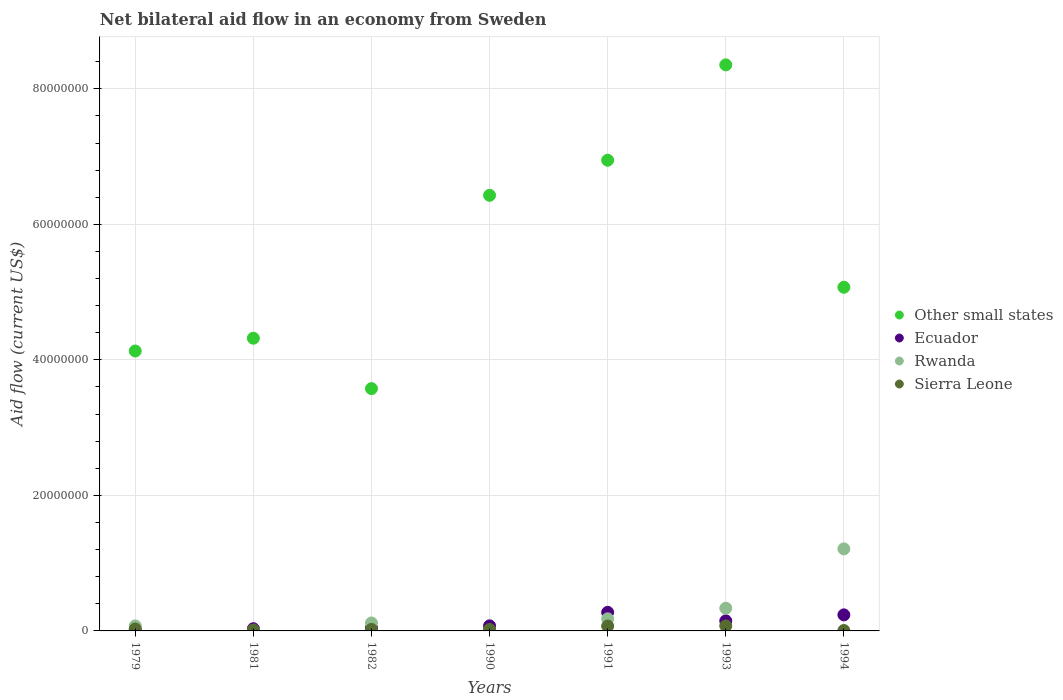What is the net bilateral aid flow in Rwanda in 1979?
Keep it short and to the point. 7.40e+05. Across all years, what is the maximum net bilateral aid flow in Ecuador?
Make the answer very short. 2.74e+06. What is the total net bilateral aid flow in Rwanda in the graph?
Offer a terse response. 1.93e+07. What is the difference between the net bilateral aid flow in Ecuador in 1982 and that in 1994?
Ensure brevity in your answer.  -1.93e+06. What is the difference between the net bilateral aid flow in Ecuador in 1979 and the net bilateral aid flow in Other small states in 1990?
Give a very brief answer. -6.42e+07. What is the average net bilateral aid flow in Ecuador per year?
Offer a terse response. 1.18e+06. In the year 1993, what is the difference between the net bilateral aid flow in Ecuador and net bilateral aid flow in Sierra Leone?
Your answer should be very brief. 7.50e+05. In how many years, is the net bilateral aid flow in Rwanda greater than 52000000 US$?
Provide a succinct answer. 0. What is the ratio of the net bilateral aid flow in Sierra Leone in 1981 to that in 1990?
Keep it short and to the point. 0.67. Is the net bilateral aid flow in Sierra Leone in 1982 less than that in 1994?
Your response must be concise. No. Is the difference between the net bilateral aid flow in Ecuador in 1982 and 1990 greater than the difference between the net bilateral aid flow in Sierra Leone in 1982 and 1990?
Your answer should be very brief. No. What is the difference between the highest and the second highest net bilateral aid flow in Other small states?
Give a very brief answer. 1.41e+07. What is the difference between the highest and the lowest net bilateral aid flow in Ecuador?
Your answer should be compact. 2.61e+06. Is the sum of the net bilateral aid flow in Other small states in 1990 and 1994 greater than the maximum net bilateral aid flow in Sierra Leone across all years?
Offer a very short reply. Yes. Is it the case that in every year, the sum of the net bilateral aid flow in Rwanda and net bilateral aid flow in Sierra Leone  is greater than the net bilateral aid flow in Other small states?
Your response must be concise. No. Does the net bilateral aid flow in Sierra Leone monotonically increase over the years?
Your response must be concise. No. Is the net bilateral aid flow in Ecuador strictly greater than the net bilateral aid flow in Rwanda over the years?
Offer a very short reply. No. Is the net bilateral aid flow in Ecuador strictly less than the net bilateral aid flow in Sierra Leone over the years?
Your response must be concise. No. How many dotlines are there?
Give a very brief answer. 4. How many years are there in the graph?
Provide a succinct answer. 7. Does the graph contain grids?
Provide a succinct answer. Yes. Where does the legend appear in the graph?
Provide a succinct answer. Center right. What is the title of the graph?
Provide a short and direct response. Net bilateral aid flow in an economy from Sweden. What is the label or title of the X-axis?
Make the answer very short. Years. What is the Aid flow (current US$) of Other small states in 1979?
Make the answer very short. 4.13e+07. What is the Aid flow (current US$) of Rwanda in 1979?
Your answer should be compact. 7.40e+05. What is the Aid flow (current US$) in Other small states in 1981?
Your answer should be compact. 4.32e+07. What is the Aid flow (current US$) in Ecuador in 1981?
Provide a short and direct response. 3.30e+05. What is the Aid flow (current US$) of Rwanda in 1981?
Keep it short and to the point. 3.00e+04. What is the Aid flow (current US$) of Sierra Leone in 1981?
Your answer should be very brief. 1.40e+05. What is the Aid flow (current US$) in Other small states in 1982?
Your answer should be very brief. 3.58e+07. What is the Aid flow (current US$) of Ecuador in 1982?
Provide a succinct answer. 4.40e+05. What is the Aid flow (current US$) of Rwanda in 1982?
Make the answer very short. 1.17e+06. What is the Aid flow (current US$) in Other small states in 1990?
Your answer should be very brief. 6.43e+07. What is the Aid flow (current US$) of Ecuador in 1990?
Offer a terse response. 7.50e+05. What is the Aid flow (current US$) of Sierra Leone in 1990?
Offer a terse response. 2.10e+05. What is the Aid flow (current US$) in Other small states in 1991?
Your answer should be compact. 6.95e+07. What is the Aid flow (current US$) of Ecuador in 1991?
Provide a short and direct response. 2.74e+06. What is the Aid flow (current US$) in Rwanda in 1991?
Provide a short and direct response. 1.79e+06. What is the Aid flow (current US$) of Sierra Leone in 1991?
Provide a short and direct response. 7.20e+05. What is the Aid flow (current US$) in Other small states in 1993?
Make the answer very short. 8.35e+07. What is the Aid flow (current US$) of Ecuador in 1993?
Your answer should be very brief. 1.49e+06. What is the Aid flow (current US$) in Rwanda in 1993?
Your response must be concise. 3.35e+06. What is the Aid flow (current US$) of Sierra Leone in 1993?
Your response must be concise. 7.40e+05. What is the Aid flow (current US$) in Other small states in 1994?
Offer a very short reply. 5.07e+07. What is the Aid flow (current US$) of Ecuador in 1994?
Your answer should be compact. 2.37e+06. What is the Aid flow (current US$) of Rwanda in 1994?
Your answer should be very brief. 1.21e+07. Across all years, what is the maximum Aid flow (current US$) in Other small states?
Your response must be concise. 8.35e+07. Across all years, what is the maximum Aid flow (current US$) of Ecuador?
Make the answer very short. 2.74e+06. Across all years, what is the maximum Aid flow (current US$) of Rwanda?
Your answer should be compact. 1.21e+07. Across all years, what is the maximum Aid flow (current US$) of Sierra Leone?
Your answer should be compact. 7.40e+05. Across all years, what is the minimum Aid flow (current US$) of Other small states?
Offer a very short reply. 3.58e+07. Across all years, what is the minimum Aid flow (current US$) of Ecuador?
Make the answer very short. 1.30e+05. Across all years, what is the minimum Aid flow (current US$) of Sierra Leone?
Provide a succinct answer. 6.00e+04. What is the total Aid flow (current US$) in Other small states in the graph?
Keep it short and to the point. 3.88e+08. What is the total Aid flow (current US$) of Ecuador in the graph?
Your answer should be compact. 8.25e+06. What is the total Aid flow (current US$) of Rwanda in the graph?
Your answer should be compact. 1.93e+07. What is the total Aid flow (current US$) of Sierra Leone in the graph?
Provide a short and direct response. 2.39e+06. What is the difference between the Aid flow (current US$) of Other small states in 1979 and that in 1981?
Keep it short and to the point. -1.89e+06. What is the difference between the Aid flow (current US$) in Ecuador in 1979 and that in 1981?
Give a very brief answer. -2.00e+05. What is the difference between the Aid flow (current US$) of Rwanda in 1979 and that in 1981?
Give a very brief answer. 7.10e+05. What is the difference between the Aid flow (current US$) in Sierra Leone in 1979 and that in 1981?
Offer a terse response. 1.50e+05. What is the difference between the Aid flow (current US$) in Other small states in 1979 and that in 1982?
Keep it short and to the point. 5.55e+06. What is the difference between the Aid flow (current US$) in Ecuador in 1979 and that in 1982?
Provide a short and direct response. -3.10e+05. What is the difference between the Aid flow (current US$) of Rwanda in 1979 and that in 1982?
Ensure brevity in your answer.  -4.30e+05. What is the difference between the Aid flow (current US$) in Other small states in 1979 and that in 1990?
Offer a terse response. -2.30e+07. What is the difference between the Aid flow (current US$) in Ecuador in 1979 and that in 1990?
Give a very brief answer. -6.20e+05. What is the difference between the Aid flow (current US$) in Rwanda in 1979 and that in 1990?
Offer a terse response. 6.10e+05. What is the difference between the Aid flow (current US$) in Sierra Leone in 1979 and that in 1990?
Offer a very short reply. 8.00e+04. What is the difference between the Aid flow (current US$) in Other small states in 1979 and that in 1991?
Ensure brevity in your answer.  -2.82e+07. What is the difference between the Aid flow (current US$) in Ecuador in 1979 and that in 1991?
Offer a terse response. -2.61e+06. What is the difference between the Aid flow (current US$) of Rwanda in 1979 and that in 1991?
Your response must be concise. -1.05e+06. What is the difference between the Aid flow (current US$) of Sierra Leone in 1979 and that in 1991?
Provide a short and direct response. -4.30e+05. What is the difference between the Aid flow (current US$) in Other small states in 1979 and that in 1993?
Provide a short and direct response. -4.22e+07. What is the difference between the Aid flow (current US$) of Ecuador in 1979 and that in 1993?
Your answer should be compact. -1.36e+06. What is the difference between the Aid flow (current US$) of Rwanda in 1979 and that in 1993?
Your answer should be very brief. -2.61e+06. What is the difference between the Aid flow (current US$) of Sierra Leone in 1979 and that in 1993?
Your response must be concise. -4.50e+05. What is the difference between the Aid flow (current US$) of Other small states in 1979 and that in 1994?
Your answer should be compact. -9.41e+06. What is the difference between the Aid flow (current US$) in Ecuador in 1979 and that in 1994?
Ensure brevity in your answer.  -2.24e+06. What is the difference between the Aid flow (current US$) in Rwanda in 1979 and that in 1994?
Ensure brevity in your answer.  -1.14e+07. What is the difference between the Aid flow (current US$) in Sierra Leone in 1979 and that in 1994?
Offer a terse response. 2.30e+05. What is the difference between the Aid flow (current US$) in Other small states in 1981 and that in 1982?
Make the answer very short. 7.44e+06. What is the difference between the Aid flow (current US$) of Ecuador in 1981 and that in 1982?
Ensure brevity in your answer.  -1.10e+05. What is the difference between the Aid flow (current US$) of Rwanda in 1981 and that in 1982?
Give a very brief answer. -1.14e+06. What is the difference between the Aid flow (current US$) in Sierra Leone in 1981 and that in 1982?
Offer a very short reply. -9.00e+04. What is the difference between the Aid flow (current US$) of Other small states in 1981 and that in 1990?
Provide a succinct answer. -2.11e+07. What is the difference between the Aid flow (current US$) in Ecuador in 1981 and that in 1990?
Your answer should be very brief. -4.20e+05. What is the difference between the Aid flow (current US$) of Sierra Leone in 1981 and that in 1990?
Your answer should be compact. -7.00e+04. What is the difference between the Aid flow (current US$) in Other small states in 1981 and that in 1991?
Provide a succinct answer. -2.63e+07. What is the difference between the Aid flow (current US$) in Ecuador in 1981 and that in 1991?
Provide a short and direct response. -2.41e+06. What is the difference between the Aid flow (current US$) in Rwanda in 1981 and that in 1991?
Give a very brief answer. -1.76e+06. What is the difference between the Aid flow (current US$) in Sierra Leone in 1981 and that in 1991?
Offer a very short reply. -5.80e+05. What is the difference between the Aid flow (current US$) of Other small states in 1981 and that in 1993?
Ensure brevity in your answer.  -4.03e+07. What is the difference between the Aid flow (current US$) of Ecuador in 1981 and that in 1993?
Offer a very short reply. -1.16e+06. What is the difference between the Aid flow (current US$) of Rwanda in 1981 and that in 1993?
Provide a short and direct response. -3.32e+06. What is the difference between the Aid flow (current US$) in Sierra Leone in 1981 and that in 1993?
Your answer should be compact. -6.00e+05. What is the difference between the Aid flow (current US$) in Other small states in 1981 and that in 1994?
Offer a very short reply. -7.52e+06. What is the difference between the Aid flow (current US$) in Ecuador in 1981 and that in 1994?
Provide a short and direct response. -2.04e+06. What is the difference between the Aid flow (current US$) of Rwanda in 1981 and that in 1994?
Make the answer very short. -1.21e+07. What is the difference between the Aid flow (current US$) in Other small states in 1982 and that in 1990?
Provide a short and direct response. -2.85e+07. What is the difference between the Aid flow (current US$) of Ecuador in 1982 and that in 1990?
Offer a terse response. -3.10e+05. What is the difference between the Aid flow (current US$) in Rwanda in 1982 and that in 1990?
Ensure brevity in your answer.  1.04e+06. What is the difference between the Aid flow (current US$) of Other small states in 1982 and that in 1991?
Keep it short and to the point. -3.37e+07. What is the difference between the Aid flow (current US$) of Ecuador in 1982 and that in 1991?
Provide a succinct answer. -2.30e+06. What is the difference between the Aid flow (current US$) in Rwanda in 1982 and that in 1991?
Offer a terse response. -6.20e+05. What is the difference between the Aid flow (current US$) in Sierra Leone in 1982 and that in 1991?
Ensure brevity in your answer.  -4.90e+05. What is the difference between the Aid flow (current US$) in Other small states in 1982 and that in 1993?
Offer a terse response. -4.78e+07. What is the difference between the Aid flow (current US$) of Ecuador in 1982 and that in 1993?
Provide a short and direct response. -1.05e+06. What is the difference between the Aid flow (current US$) of Rwanda in 1982 and that in 1993?
Offer a terse response. -2.18e+06. What is the difference between the Aid flow (current US$) in Sierra Leone in 1982 and that in 1993?
Offer a very short reply. -5.10e+05. What is the difference between the Aid flow (current US$) in Other small states in 1982 and that in 1994?
Provide a short and direct response. -1.50e+07. What is the difference between the Aid flow (current US$) in Ecuador in 1982 and that in 1994?
Give a very brief answer. -1.93e+06. What is the difference between the Aid flow (current US$) of Rwanda in 1982 and that in 1994?
Offer a terse response. -1.09e+07. What is the difference between the Aid flow (current US$) in Sierra Leone in 1982 and that in 1994?
Your answer should be very brief. 1.70e+05. What is the difference between the Aid flow (current US$) of Other small states in 1990 and that in 1991?
Offer a terse response. -5.18e+06. What is the difference between the Aid flow (current US$) in Ecuador in 1990 and that in 1991?
Your answer should be compact. -1.99e+06. What is the difference between the Aid flow (current US$) of Rwanda in 1990 and that in 1991?
Make the answer very short. -1.66e+06. What is the difference between the Aid flow (current US$) of Sierra Leone in 1990 and that in 1991?
Your response must be concise. -5.10e+05. What is the difference between the Aid flow (current US$) of Other small states in 1990 and that in 1993?
Provide a succinct answer. -1.92e+07. What is the difference between the Aid flow (current US$) of Ecuador in 1990 and that in 1993?
Your answer should be very brief. -7.40e+05. What is the difference between the Aid flow (current US$) of Rwanda in 1990 and that in 1993?
Provide a succinct answer. -3.22e+06. What is the difference between the Aid flow (current US$) in Sierra Leone in 1990 and that in 1993?
Make the answer very short. -5.30e+05. What is the difference between the Aid flow (current US$) of Other small states in 1990 and that in 1994?
Keep it short and to the point. 1.36e+07. What is the difference between the Aid flow (current US$) of Ecuador in 1990 and that in 1994?
Your answer should be very brief. -1.62e+06. What is the difference between the Aid flow (current US$) in Rwanda in 1990 and that in 1994?
Provide a succinct answer. -1.20e+07. What is the difference between the Aid flow (current US$) of Sierra Leone in 1990 and that in 1994?
Make the answer very short. 1.50e+05. What is the difference between the Aid flow (current US$) of Other small states in 1991 and that in 1993?
Ensure brevity in your answer.  -1.41e+07. What is the difference between the Aid flow (current US$) in Ecuador in 1991 and that in 1993?
Your answer should be very brief. 1.25e+06. What is the difference between the Aid flow (current US$) in Rwanda in 1991 and that in 1993?
Your answer should be very brief. -1.56e+06. What is the difference between the Aid flow (current US$) in Sierra Leone in 1991 and that in 1993?
Provide a short and direct response. -2.00e+04. What is the difference between the Aid flow (current US$) in Other small states in 1991 and that in 1994?
Keep it short and to the point. 1.88e+07. What is the difference between the Aid flow (current US$) of Ecuador in 1991 and that in 1994?
Offer a terse response. 3.70e+05. What is the difference between the Aid flow (current US$) of Rwanda in 1991 and that in 1994?
Keep it short and to the point. -1.03e+07. What is the difference between the Aid flow (current US$) in Other small states in 1993 and that in 1994?
Keep it short and to the point. 3.28e+07. What is the difference between the Aid flow (current US$) in Ecuador in 1993 and that in 1994?
Your answer should be very brief. -8.80e+05. What is the difference between the Aid flow (current US$) in Rwanda in 1993 and that in 1994?
Keep it short and to the point. -8.76e+06. What is the difference between the Aid flow (current US$) in Sierra Leone in 1993 and that in 1994?
Give a very brief answer. 6.80e+05. What is the difference between the Aid flow (current US$) in Other small states in 1979 and the Aid flow (current US$) in Ecuador in 1981?
Ensure brevity in your answer.  4.10e+07. What is the difference between the Aid flow (current US$) of Other small states in 1979 and the Aid flow (current US$) of Rwanda in 1981?
Offer a terse response. 4.13e+07. What is the difference between the Aid flow (current US$) of Other small states in 1979 and the Aid flow (current US$) of Sierra Leone in 1981?
Make the answer very short. 4.12e+07. What is the difference between the Aid flow (current US$) of Ecuador in 1979 and the Aid flow (current US$) of Sierra Leone in 1981?
Keep it short and to the point. -10000. What is the difference between the Aid flow (current US$) of Rwanda in 1979 and the Aid flow (current US$) of Sierra Leone in 1981?
Provide a succinct answer. 6.00e+05. What is the difference between the Aid flow (current US$) in Other small states in 1979 and the Aid flow (current US$) in Ecuador in 1982?
Your response must be concise. 4.09e+07. What is the difference between the Aid flow (current US$) of Other small states in 1979 and the Aid flow (current US$) of Rwanda in 1982?
Give a very brief answer. 4.01e+07. What is the difference between the Aid flow (current US$) of Other small states in 1979 and the Aid flow (current US$) of Sierra Leone in 1982?
Make the answer very short. 4.11e+07. What is the difference between the Aid flow (current US$) in Ecuador in 1979 and the Aid flow (current US$) in Rwanda in 1982?
Ensure brevity in your answer.  -1.04e+06. What is the difference between the Aid flow (current US$) of Ecuador in 1979 and the Aid flow (current US$) of Sierra Leone in 1982?
Your answer should be compact. -1.00e+05. What is the difference between the Aid flow (current US$) of Rwanda in 1979 and the Aid flow (current US$) of Sierra Leone in 1982?
Ensure brevity in your answer.  5.10e+05. What is the difference between the Aid flow (current US$) in Other small states in 1979 and the Aid flow (current US$) in Ecuador in 1990?
Make the answer very short. 4.06e+07. What is the difference between the Aid flow (current US$) of Other small states in 1979 and the Aid flow (current US$) of Rwanda in 1990?
Keep it short and to the point. 4.12e+07. What is the difference between the Aid flow (current US$) in Other small states in 1979 and the Aid flow (current US$) in Sierra Leone in 1990?
Make the answer very short. 4.11e+07. What is the difference between the Aid flow (current US$) of Ecuador in 1979 and the Aid flow (current US$) of Rwanda in 1990?
Ensure brevity in your answer.  0. What is the difference between the Aid flow (current US$) in Ecuador in 1979 and the Aid flow (current US$) in Sierra Leone in 1990?
Give a very brief answer. -8.00e+04. What is the difference between the Aid flow (current US$) in Rwanda in 1979 and the Aid flow (current US$) in Sierra Leone in 1990?
Give a very brief answer. 5.30e+05. What is the difference between the Aid flow (current US$) in Other small states in 1979 and the Aid flow (current US$) in Ecuador in 1991?
Give a very brief answer. 3.86e+07. What is the difference between the Aid flow (current US$) in Other small states in 1979 and the Aid flow (current US$) in Rwanda in 1991?
Your response must be concise. 3.95e+07. What is the difference between the Aid flow (current US$) of Other small states in 1979 and the Aid flow (current US$) of Sierra Leone in 1991?
Offer a very short reply. 4.06e+07. What is the difference between the Aid flow (current US$) of Ecuador in 1979 and the Aid flow (current US$) of Rwanda in 1991?
Your response must be concise. -1.66e+06. What is the difference between the Aid flow (current US$) in Ecuador in 1979 and the Aid flow (current US$) in Sierra Leone in 1991?
Offer a very short reply. -5.90e+05. What is the difference between the Aid flow (current US$) in Rwanda in 1979 and the Aid flow (current US$) in Sierra Leone in 1991?
Ensure brevity in your answer.  2.00e+04. What is the difference between the Aid flow (current US$) of Other small states in 1979 and the Aid flow (current US$) of Ecuador in 1993?
Offer a very short reply. 3.98e+07. What is the difference between the Aid flow (current US$) in Other small states in 1979 and the Aid flow (current US$) in Rwanda in 1993?
Your response must be concise. 3.80e+07. What is the difference between the Aid flow (current US$) of Other small states in 1979 and the Aid flow (current US$) of Sierra Leone in 1993?
Make the answer very short. 4.06e+07. What is the difference between the Aid flow (current US$) of Ecuador in 1979 and the Aid flow (current US$) of Rwanda in 1993?
Give a very brief answer. -3.22e+06. What is the difference between the Aid flow (current US$) in Ecuador in 1979 and the Aid flow (current US$) in Sierra Leone in 1993?
Your response must be concise. -6.10e+05. What is the difference between the Aid flow (current US$) of Rwanda in 1979 and the Aid flow (current US$) of Sierra Leone in 1993?
Your answer should be very brief. 0. What is the difference between the Aid flow (current US$) of Other small states in 1979 and the Aid flow (current US$) of Ecuador in 1994?
Ensure brevity in your answer.  3.89e+07. What is the difference between the Aid flow (current US$) in Other small states in 1979 and the Aid flow (current US$) in Rwanda in 1994?
Make the answer very short. 2.92e+07. What is the difference between the Aid flow (current US$) in Other small states in 1979 and the Aid flow (current US$) in Sierra Leone in 1994?
Make the answer very short. 4.12e+07. What is the difference between the Aid flow (current US$) in Ecuador in 1979 and the Aid flow (current US$) in Rwanda in 1994?
Give a very brief answer. -1.20e+07. What is the difference between the Aid flow (current US$) in Rwanda in 1979 and the Aid flow (current US$) in Sierra Leone in 1994?
Ensure brevity in your answer.  6.80e+05. What is the difference between the Aid flow (current US$) of Other small states in 1981 and the Aid flow (current US$) of Ecuador in 1982?
Offer a terse response. 4.28e+07. What is the difference between the Aid flow (current US$) in Other small states in 1981 and the Aid flow (current US$) in Rwanda in 1982?
Your answer should be very brief. 4.20e+07. What is the difference between the Aid flow (current US$) of Other small states in 1981 and the Aid flow (current US$) of Sierra Leone in 1982?
Your answer should be very brief. 4.30e+07. What is the difference between the Aid flow (current US$) of Ecuador in 1981 and the Aid flow (current US$) of Rwanda in 1982?
Offer a terse response. -8.40e+05. What is the difference between the Aid flow (current US$) in Rwanda in 1981 and the Aid flow (current US$) in Sierra Leone in 1982?
Provide a short and direct response. -2.00e+05. What is the difference between the Aid flow (current US$) of Other small states in 1981 and the Aid flow (current US$) of Ecuador in 1990?
Offer a very short reply. 4.24e+07. What is the difference between the Aid flow (current US$) of Other small states in 1981 and the Aid flow (current US$) of Rwanda in 1990?
Make the answer very short. 4.31e+07. What is the difference between the Aid flow (current US$) in Other small states in 1981 and the Aid flow (current US$) in Sierra Leone in 1990?
Your answer should be compact. 4.30e+07. What is the difference between the Aid flow (current US$) of Ecuador in 1981 and the Aid flow (current US$) of Rwanda in 1990?
Your answer should be very brief. 2.00e+05. What is the difference between the Aid flow (current US$) in Ecuador in 1981 and the Aid flow (current US$) in Sierra Leone in 1990?
Provide a succinct answer. 1.20e+05. What is the difference between the Aid flow (current US$) of Rwanda in 1981 and the Aid flow (current US$) of Sierra Leone in 1990?
Offer a terse response. -1.80e+05. What is the difference between the Aid flow (current US$) of Other small states in 1981 and the Aid flow (current US$) of Ecuador in 1991?
Your response must be concise. 4.05e+07. What is the difference between the Aid flow (current US$) in Other small states in 1981 and the Aid flow (current US$) in Rwanda in 1991?
Keep it short and to the point. 4.14e+07. What is the difference between the Aid flow (current US$) in Other small states in 1981 and the Aid flow (current US$) in Sierra Leone in 1991?
Offer a terse response. 4.25e+07. What is the difference between the Aid flow (current US$) of Ecuador in 1981 and the Aid flow (current US$) of Rwanda in 1991?
Provide a short and direct response. -1.46e+06. What is the difference between the Aid flow (current US$) of Ecuador in 1981 and the Aid flow (current US$) of Sierra Leone in 1991?
Offer a very short reply. -3.90e+05. What is the difference between the Aid flow (current US$) of Rwanda in 1981 and the Aid flow (current US$) of Sierra Leone in 1991?
Offer a terse response. -6.90e+05. What is the difference between the Aid flow (current US$) in Other small states in 1981 and the Aid flow (current US$) in Ecuador in 1993?
Offer a very short reply. 4.17e+07. What is the difference between the Aid flow (current US$) in Other small states in 1981 and the Aid flow (current US$) in Rwanda in 1993?
Offer a terse response. 3.98e+07. What is the difference between the Aid flow (current US$) in Other small states in 1981 and the Aid flow (current US$) in Sierra Leone in 1993?
Provide a succinct answer. 4.25e+07. What is the difference between the Aid flow (current US$) in Ecuador in 1981 and the Aid flow (current US$) in Rwanda in 1993?
Provide a succinct answer. -3.02e+06. What is the difference between the Aid flow (current US$) of Ecuador in 1981 and the Aid flow (current US$) of Sierra Leone in 1993?
Make the answer very short. -4.10e+05. What is the difference between the Aid flow (current US$) of Rwanda in 1981 and the Aid flow (current US$) of Sierra Leone in 1993?
Give a very brief answer. -7.10e+05. What is the difference between the Aid flow (current US$) in Other small states in 1981 and the Aid flow (current US$) in Ecuador in 1994?
Your response must be concise. 4.08e+07. What is the difference between the Aid flow (current US$) of Other small states in 1981 and the Aid flow (current US$) of Rwanda in 1994?
Offer a very short reply. 3.11e+07. What is the difference between the Aid flow (current US$) in Other small states in 1981 and the Aid flow (current US$) in Sierra Leone in 1994?
Provide a short and direct response. 4.31e+07. What is the difference between the Aid flow (current US$) in Ecuador in 1981 and the Aid flow (current US$) in Rwanda in 1994?
Offer a very short reply. -1.18e+07. What is the difference between the Aid flow (current US$) in Ecuador in 1981 and the Aid flow (current US$) in Sierra Leone in 1994?
Ensure brevity in your answer.  2.70e+05. What is the difference between the Aid flow (current US$) in Other small states in 1982 and the Aid flow (current US$) in Ecuador in 1990?
Make the answer very short. 3.50e+07. What is the difference between the Aid flow (current US$) in Other small states in 1982 and the Aid flow (current US$) in Rwanda in 1990?
Provide a succinct answer. 3.56e+07. What is the difference between the Aid flow (current US$) in Other small states in 1982 and the Aid flow (current US$) in Sierra Leone in 1990?
Offer a terse response. 3.56e+07. What is the difference between the Aid flow (current US$) of Rwanda in 1982 and the Aid flow (current US$) of Sierra Leone in 1990?
Your answer should be very brief. 9.60e+05. What is the difference between the Aid flow (current US$) of Other small states in 1982 and the Aid flow (current US$) of Ecuador in 1991?
Give a very brief answer. 3.30e+07. What is the difference between the Aid flow (current US$) in Other small states in 1982 and the Aid flow (current US$) in Rwanda in 1991?
Offer a very short reply. 3.40e+07. What is the difference between the Aid flow (current US$) in Other small states in 1982 and the Aid flow (current US$) in Sierra Leone in 1991?
Ensure brevity in your answer.  3.50e+07. What is the difference between the Aid flow (current US$) in Ecuador in 1982 and the Aid flow (current US$) in Rwanda in 1991?
Your answer should be compact. -1.35e+06. What is the difference between the Aid flow (current US$) in Ecuador in 1982 and the Aid flow (current US$) in Sierra Leone in 1991?
Your response must be concise. -2.80e+05. What is the difference between the Aid flow (current US$) of Other small states in 1982 and the Aid flow (current US$) of Ecuador in 1993?
Your answer should be very brief. 3.43e+07. What is the difference between the Aid flow (current US$) in Other small states in 1982 and the Aid flow (current US$) in Rwanda in 1993?
Make the answer very short. 3.24e+07. What is the difference between the Aid flow (current US$) in Other small states in 1982 and the Aid flow (current US$) in Sierra Leone in 1993?
Your response must be concise. 3.50e+07. What is the difference between the Aid flow (current US$) in Ecuador in 1982 and the Aid flow (current US$) in Rwanda in 1993?
Provide a short and direct response. -2.91e+06. What is the difference between the Aid flow (current US$) in Other small states in 1982 and the Aid flow (current US$) in Ecuador in 1994?
Your response must be concise. 3.34e+07. What is the difference between the Aid flow (current US$) of Other small states in 1982 and the Aid flow (current US$) of Rwanda in 1994?
Provide a succinct answer. 2.36e+07. What is the difference between the Aid flow (current US$) in Other small states in 1982 and the Aid flow (current US$) in Sierra Leone in 1994?
Offer a very short reply. 3.57e+07. What is the difference between the Aid flow (current US$) in Ecuador in 1982 and the Aid flow (current US$) in Rwanda in 1994?
Keep it short and to the point. -1.17e+07. What is the difference between the Aid flow (current US$) in Rwanda in 1982 and the Aid flow (current US$) in Sierra Leone in 1994?
Offer a terse response. 1.11e+06. What is the difference between the Aid flow (current US$) of Other small states in 1990 and the Aid flow (current US$) of Ecuador in 1991?
Your answer should be very brief. 6.16e+07. What is the difference between the Aid flow (current US$) in Other small states in 1990 and the Aid flow (current US$) in Rwanda in 1991?
Your answer should be compact. 6.25e+07. What is the difference between the Aid flow (current US$) of Other small states in 1990 and the Aid flow (current US$) of Sierra Leone in 1991?
Offer a very short reply. 6.36e+07. What is the difference between the Aid flow (current US$) in Ecuador in 1990 and the Aid flow (current US$) in Rwanda in 1991?
Ensure brevity in your answer.  -1.04e+06. What is the difference between the Aid flow (current US$) of Ecuador in 1990 and the Aid flow (current US$) of Sierra Leone in 1991?
Provide a succinct answer. 3.00e+04. What is the difference between the Aid flow (current US$) of Rwanda in 1990 and the Aid flow (current US$) of Sierra Leone in 1991?
Ensure brevity in your answer.  -5.90e+05. What is the difference between the Aid flow (current US$) of Other small states in 1990 and the Aid flow (current US$) of Ecuador in 1993?
Make the answer very short. 6.28e+07. What is the difference between the Aid flow (current US$) of Other small states in 1990 and the Aid flow (current US$) of Rwanda in 1993?
Offer a terse response. 6.09e+07. What is the difference between the Aid flow (current US$) of Other small states in 1990 and the Aid flow (current US$) of Sierra Leone in 1993?
Your answer should be very brief. 6.36e+07. What is the difference between the Aid flow (current US$) of Ecuador in 1990 and the Aid flow (current US$) of Rwanda in 1993?
Provide a short and direct response. -2.60e+06. What is the difference between the Aid flow (current US$) in Ecuador in 1990 and the Aid flow (current US$) in Sierra Leone in 1993?
Give a very brief answer. 10000. What is the difference between the Aid flow (current US$) in Rwanda in 1990 and the Aid flow (current US$) in Sierra Leone in 1993?
Provide a short and direct response. -6.10e+05. What is the difference between the Aid flow (current US$) of Other small states in 1990 and the Aid flow (current US$) of Ecuador in 1994?
Offer a terse response. 6.19e+07. What is the difference between the Aid flow (current US$) in Other small states in 1990 and the Aid flow (current US$) in Rwanda in 1994?
Your answer should be very brief. 5.22e+07. What is the difference between the Aid flow (current US$) of Other small states in 1990 and the Aid flow (current US$) of Sierra Leone in 1994?
Ensure brevity in your answer.  6.42e+07. What is the difference between the Aid flow (current US$) of Ecuador in 1990 and the Aid flow (current US$) of Rwanda in 1994?
Provide a succinct answer. -1.14e+07. What is the difference between the Aid flow (current US$) of Ecuador in 1990 and the Aid flow (current US$) of Sierra Leone in 1994?
Offer a very short reply. 6.90e+05. What is the difference between the Aid flow (current US$) in Other small states in 1991 and the Aid flow (current US$) in Ecuador in 1993?
Your answer should be very brief. 6.80e+07. What is the difference between the Aid flow (current US$) in Other small states in 1991 and the Aid flow (current US$) in Rwanda in 1993?
Provide a short and direct response. 6.61e+07. What is the difference between the Aid flow (current US$) of Other small states in 1991 and the Aid flow (current US$) of Sierra Leone in 1993?
Your answer should be very brief. 6.87e+07. What is the difference between the Aid flow (current US$) in Ecuador in 1991 and the Aid flow (current US$) in Rwanda in 1993?
Make the answer very short. -6.10e+05. What is the difference between the Aid flow (current US$) in Ecuador in 1991 and the Aid flow (current US$) in Sierra Leone in 1993?
Provide a short and direct response. 2.00e+06. What is the difference between the Aid flow (current US$) of Rwanda in 1991 and the Aid flow (current US$) of Sierra Leone in 1993?
Give a very brief answer. 1.05e+06. What is the difference between the Aid flow (current US$) of Other small states in 1991 and the Aid flow (current US$) of Ecuador in 1994?
Ensure brevity in your answer.  6.71e+07. What is the difference between the Aid flow (current US$) in Other small states in 1991 and the Aid flow (current US$) in Rwanda in 1994?
Your answer should be compact. 5.74e+07. What is the difference between the Aid flow (current US$) of Other small states in 1991 and the Aid flow (current US$) of Sierra Leone in 1994?
Keep it short and to the point. 6.94e+07. What is the difference between the Aid flow (current US$) of Ecuador in 1991 and the Aid flow (current US$) of Rwanda in 1994?
Offer a very short reply. -9.37e+06. What is the difference between the Aid flow (current US$) in Ecuador in 1991 and the Aid flow (current US$) in Sierra Leone in 1994?
Ensure brevity in your answer.  2.68e+06. What is the difference between the Aid flow (current US$) in Rwanda in 1991 and the Aid flow (current US$) in Sierra Leone in 1994?
Keep it short and to the point. 1.73e+06. What is the difference between the Aid flow (current US$) in Other small states in 1993 and the Aid flow (current US$) in Ecuador in 1994?
Give a very brief answer. 8.12e+07. What is the difference between the Aid flow (current US$) of Other small states in 1993 and the Aid flow (current US$) of Rwanda in 1994?
Your answer should be very brief. 7.14e+07. What is the difference between the Aid flow (current US$) in Other small states in 1993 and the Aid flow (current US$) in Sierra Leone in 1994?
Ensure brevity in your answer.  8.35e+07. What is the difference between the Aid flow (current US$) in Ecuador in 1993 and the Aid flow (current US$) in Rwanda in 1994?
Provide a short and direct response. -1.06e+07. What is the difference between the Aid flow (current US$) of Ecuador in 1993 and the Aid flow (current US$) of Sierra Leone in 1994?
Provide a short and direct response. 1.43e+06. What is the difference between the Aid flow (current US$) of Rwanda in 1993 and the Aid flow (current US$) of Sierra Leone in 1994?
Provide a succinct answer. 3.29e+06. What is the average Aid flow (current US$) in Other small states per year?
Keep it short and to the point. 5.55e+07. What is the average Aid flow (current US$) in Ecuador per year?
Offer a terse response. 1.18e+06. What is the average Aid flow (current US$) in Rwanda per year?
Make the answer very short. 2.76e+06. What is the average Aid flow (current US$) in Sierra Leone per year?
Ensure brevity in your answer.  3.41e+05. In the year 1979, what is the difference between the Aid flow (current US$) of Other small states and Aid flow (current US$) of Ecuador?
Give a very brief answer. 4.12e+07. In the year 1979, what is the difference between the Aid flow (current US$) in Other small states and Aid flow (current US$) in Rwanda?
Provide a short and direct response. 4.06e+07. In the year 1979, what is the difference between the Aid flow (current US$) of Other small states and Aid flow (current US$) of Sierra Leone?
Offer a very short reply. 4.10e+07. In the year 1979, what is the difference between the Aid flow (current US$) of Ecuador and Aid flow (current US$) of Rwanda?
Provide a succinct answer. -6.10e+05. In the year 1979, what is the difference between the Aid flow (current US$) of Ecuador and Aid flow (current US$) of Sierra Leone?
Your answer should be very brief. -1.60e+05. In the year 1979, what is the difference between the Aid flow (current US$) of Rwanda and Aid flow (current US$) of Sierra Leone?
Your answer should be very brief. 4.50e+05. In the year 1981, what is the difference between the Aid flow (current US$) of Other small states and Aid flow (current US$) of Ecuador?
Offer a very short reply. 4.29e+07. In the year 1981, what is the difference between the Aid flow (current US$) in Other small states and Aid flow (current US$) in Rwanda?
Give a very brief answer. 4.32e+07. In the year 1981, what is the difference between the Aid flow (current US$) in Other small states and Aid flow (current US$) in Sierra Leone?
Provide a short and direct response. 4.31e+07. In the year 1981, what is the difference between the Aid flow (current US$) in Ecuador and Aid flow (current US$) in Sierra Leone?
Offer a very short reply. 1.90e+05. In the year 1982, what is the difference between the Aid flow (current US$) of Other small states and Aid flow (current US$) of Ecuador?
Provide a short and direct response. 3.53e+07. In the year 1982, what is the difference between the Aid flow (current US$) in Other small states and Aid flow (current US$) in Rwanda?
Offer a very short reply. 3.46e+07. In the year 1982, what is the difference between the Aid flow (current US$) of Other small states and Aid flow (current US$) of Sierra Leone?
Ensure brevity in your answer.  3.55e+07. In the year 1982, what is the difference between the Aid flow (current US$) in Ecuador and Aid flow (current US$) in Rwanda?
Give a very brief answer. -7.30e+05. In the year 1982, what is the difference between the Aid flow (current US$) of Ecuador and Aid flow (current US$) of Sierra Leone?
Your answer should be very brief. 2.10e+05. In the year 1982, what is the difference between the Aid flow (current US$) of Rwanda and Aid flow (current US$) of Sierra Leone?
Offer a terse response. 9.40e+05. In the year 1990, what is the difference between the Aid flow (current US$) of Other small states and Aid flow (current US$) of Ecuador?
Keep it short and to the point. 6.35e+07. In the year 1990, what is the difference between the Aid flow (current US$) of Other small states and Aid flow (current US$) of Rwanda?
Give a very brief answer. 6.42e+07. In the year 1990, what is the difference between the Aid flow (current US$) in Other small states and Aid flow (current US$) in Sierra Leone?
Offer a terse response. 6.41e+07. In the year 1990, what is the difference between the Aid flow (current US$) in Ecuador and Aid flow (current US$) in Rwanda?
Provide a succinct answer. 6.20e+05. In the year 1990, what is the difference between the Aid flow (current US$) of Ecuador and Aid flow (current US$) of Sierra Leone?
Offer a terse response. 5.40e+05. In the year 1991, what is the difference between the Aid flow (current US$) of Other small states and Aid flow (current US$) of Ecuador?
Your answer should be very brief. 6.67e+07. In the year 1991, what is the difference between the Aid flow (current US$) in Other small states and Aid flow (current US$) in Rwanda?
Offer a terse response. 6.77e+07. In the year 1991, what is the difference between the Aid flow (current US$) of Other small states and Aid flow (current US$) of Sierra Leone?
Keep it short and to the point. 6.88e+07. In the year 1991, what is the difference between the Aid flow (current US$) of Ecuador and Aid flow (current US$) of Rwanda?
Give a very brief answer. 9.50e+05. In the year 1991, what is the difference between the Aid flow (current US$) in Ecuador and Aid flow (current US$) in Sierra Leone?
Provide a succinct answer. 2.02e+06. In the year 1991, what is the difference between the Aid flow (current US$) in Rwanda and Aid flow (current US$) in Sierra Leone?
Your answer should be compact. 1.07e+06. In the year 1993, what is the difference between the Aid flow (current US$) of Other small states and Aid flow (current US$) of Ecuador?
Provide a succinct answer. 8.20e+07. In the year 1993, what is the difference between the Aid flow (current US$) of Other small states and Aid flow (current US$) of Rwanda?
Provide a short and direct response. 8.02e+07. In the year 1993, what is the difference between the Aid flow (current US$) in Other small states and Aid flow (current US$) in Sierra Leone?
Provide a succinct answer. 8.28e+07. In the year 1993, what is the difference between the Aid flow (current US$) of Ecuador and Aid flow (current US$) of Rwanda?
Your response must be concise. -1.86e+06. In the year 1993, what is the difference between the Aid flow (current US$) in Ecuador and Aid flow (current US$) in Sierra Leone?
Your answer should be very brief. 7.50e+05. In the year 1993, what is the difference between the Aid flow (current US$) in Rwanda and Aid flow (current US$) in Sierra Leone?
Your response must be concise. 2.61e+06. In the year 1994, what is the difference between the Aid flow (current US$) of Other small states and Aid flow (current US$) of Ecuador?
Make the answer very short. 4.84e+07. In the year 1994, what is the difference between the Aid flow (current US$) of Other small states and Aid flow (current US$) of Rwanda?
Your response must be concise. 3.86e+07. In the year 1994, what is the difference between the Aid flow (current US$) in Other small states and Aid flow (current US$) in Sierra Leone?
Keep it short and to the point. 5.07e+07. In the year 1994, what is the difference between the Aid flow (current US$) of Ecuador and Aid flow (current US$) of Rwanda?
Offer a very short reply. -9.74e+06. In the year 1994, what is the difference between the Aid flow (current US$) of Ecuador and Aid flow (current US$) of Sierra Leone?
Provide a short and direct response. 2.31e+06. In the year 1994, what is the difference between the Aid flow (current US$) of Rwanda and Aid flow (current US$) of Sierra Leone?
Provide a short and direct response. 1.20e+07. What is the ratio of the Aid flow (current US$) in Other small states in 1979 to that in 1981?
Give a very brief answer. 0.96. What is the ratio of the Aid flow (current US$) in Ecuador in 1979 to that in 1981?
Make the answer very short. 0.39. What is the ratio of the Aid flow (current US$) of Rwanda in 1979 to that in 1981?
Ensure brevity in your answer.  24.67. What is the ratio of the Aid flow (current US$) of Sierra Leone in 1979 to that in 1981?
Your answer should be compact. 2.07. What is the ratio of the Aid flow (current US$) in Other small states in 1979 to that in 1982?
Give a very brief answer. 1.16. What is the ratio of the Aid flow (current US$) in Ecuador in 1979 to that in 1982?
Your answer should be compact. 0.3. What is the ratio of the Aid flow (current US$) in Rwanda in 1979 to that in 1982?
Give a very brief answer. 0.63. What is the ratio of the Aid flow (current US$) in Sierra Leone in 1979 to that in 1982?
Ensure brevity in your answer.  1.26. What is the ratio of the Aid flow (current US$) in Other small states in 1979 to that in 1990?
Provide a short and direct response. 0.64. What is the ratio of the Aid flow (current US$) of Ecuador in 1979 to that in 1990?
Give a very brief answer. 0.17. What is the ratio of the Aid flow (current US$) in Rwanda in 1979 to that in 1990?
Ensure brevity in your answer.  5.69. What is the ratio of the Aid flow (current US$) in Sierra Leone in 1979 to that in 1990?
Your answer should be very brief. 1.38. What is the ratio of the Aid flow (current US$) in Other small states in 1979 to that in 1991?
Your answer should be compact. 0.59. What is the ratio of the Aid flow (current US$) in Ecuador in 1979 to that in 1991?
Offer a terse response. 0.05. What is the ratio of the Aid flow (current US$) of Rwanda in 1979 to that in 1991?
Ensure brevity in your answer.  0.41. What is the ratio of the Aid flow (current US$) of Sierra Leone in 1979 to that in 1991?
Provide a succinct answer. 0.4. What is the ratio of the Aid flow (current US$) of Other small states in 1979 to that in 1993?
Offer a terse response. 0.49. What is the ratio of the Aid flow (current US$) in Ecuador in 1979 to that in 1993?
Offer a terse response. 0.09. What is the ratio of the Aid flow (current US$) of Rwanda in 1979 to that in 1993?
Give a very brief answer. 0.22. What is the ratio of the Aid flow (current US$) of Sierra Leone in 1979 to that in 1993?
Provide a succinct answer. 0.39. What is the ratio of the Aid flow (current US$) of Other small states in 1979 to that in 1994?
Your answer should be very brief. 0.81. What is the ratio of the Aid flow (current US$) in Ecuador in 1979 to that in 1994?
Your response must be concise. 0.05. What is the ratio of the Aid flow (current US$) in Rwanda in 1979 to that in 1994?
Offer a very short reply. 0.06. What is the ratio of the Aid flow (current US$) in Sierra Leone in 1979 to that in 1994?
Your answer should be very brief. 4.83. What is the ratio of the Aid flow (current US$) of Other small states in 1981 to that in 1982?
Your answer should be very brief. 1.21. What is the ratio of the Aid flow (current US$) in Rwanda in 1981 to that in 1982?
Make the answer very short. 0.03. What is the ratio of the Aid flow (current US$) in Sierra Leone in 1981 to that in 1982?
Your answer should be compact. 0.61. What is the ratio of the Aid flow (current US$) of Other small states in 1981 to that in 1990?
Your answer should be compact. 0.67. What is the ratio of the Aid flow (current US$) of Ecuador in 1981 to that in 1990?
Provide a succinct answer. 0.44. What is the ratio of the Aid flow (current US$) in Rwanda in 1981 to that in 1990?
Provide a succinct answer. 0.23. What is the ratio of the Aid flow (current US$) in Sierra Leone in 1981 to that in 1990?
Your answer should be very brief. 0.67. What is the ratio of the Aid flow (current US$) of Other small states in 1981 to that in 1991?
Your answer should be very brief. 0.62. What is the ratio of the Aid flow (current US$) of Ecuador in 1981 to that in 1991?
Your answer should be compact. 0.12. What is the ratio of the Aid flow (current US$) in Rwanda in 1981 to that in 1991?
Make the answer very short. 0.02. What is the ratio of the Aid flow (current US$) of Sierra Leone in 1981 to that in 1991?
Offer a terse response. 0.19. What is the ratio of the Aid flow (current US$) in Other small states in 1981 to that in 1993?
Your response must be concise. 0.52. What is the ratio of the Aid flow (current US$) of Ecuador in 1981 to that in 1993?
Give a very brief answer. 0.22. What is the ratio of the Aid flow (current US$) in Rwanda in 1981 to that in 1993?
Your response must be concise. 0.01. What is the ratio of the Aid flow (current US$) in Sierra Leone in 1981 to that in 1993?
Give a very brief answer. 0.19. What is the ratio of the Aid flow (current US$) in Other small states in 1981 to that in 1994?
Offer a terse response. 0.85. What is the ratio of the Aid flow (current US$) in Ecuador in 1981 to that in 1994?
Give a very brief answer. 0.14. What is the ratio of the Aid flow (current US$) of Rwanda in 1981 to that in 1994?
Offer a very short reply. 0. What is the ratio of the Aid flow (current US$) of Sierra Leone in 1981 to that in 1994?
Offer a terse response. 2.33. What is the ratio of the Aid flow (current US$) of Other small states in 1982 to that in 1990?
Keep it short and to the point. 0.56. What is the ratio of the Aid flow (current US$) of Ecuador in 1982 to that in 1990?
Ensure brevity in your answer.  0.59. What is the ratio of the Aid flow (current US$) in Sierra Leone in 1982 to that in 1990?
Your answer should be very brief. 1.1. What is the ratio of the Aid flow (current US$) of Other small states in 1982 to that in 1991?
Provide a short and direct response. 0.51. What is the ratio of the Aid flow (current US$) of Ecuador in 1982 to that in 1991?
Provide a succinct answer. 0.16. What is the ratio of the Aid flow (current US$) of Rwanda in 1982 to that in 1991?
Provide a succinct answer. 0.65. What is the ratio of the Aid flow (current US$) in Sierra Leone in 1982 to that in 1991?
Keep it short and to the point. 0.32. What is the ratio of the Aid flow (current US$) in Other small states in 1982 to that in 1993?
Offer a terse response. 0.43. What is the ratio of the Aid flow (current US$) of Ecuador in 1982 to that in 1993?
Ensure brevity in your answer.  0.3. What is the ratio of the Aid flow (current US$) in Rwanda in 1982 to that in 1993?
Offer a very short reply. 0.35. What is the ratio of the Aid flow (current US$) in Sierra Leone in 1982 to that in 1993?
Ensure brevity in your answer.  0.31. What is the ratio of the Aid flow (current US$) of Other small states in 1982 to that in 1994?
Keep it short and to the point. 0.7. What is the ratio of the Aid flow (current US$) in Ecuador in 1982 to that in 1994?
Provide a succinct answer. 0.19. What is the ratio of the Aid flow (current US$) of Rwanda in 1982 to that in 1994?
Keep it short and to the point. 0.1. What is the ratio of the Aid flow (current US$) in Sierra Leone in 1982 to that in 1994?
Make the answer very short. 3.83. What is the ratio of the Aid flow (current US$) in Other small states in 1990 to that in 1991?
Keep it short and to the point. 0.93. What is the ratio of the Aid flow (current US$) of Ecuador in 1990 to that in 1991?
Your answer should be very brief. 0.27. What is the ratio of the Aid flow (current US$) of Rwanda in 1990 to that in 1991?
Keep it short and to the point. 0.07. What is the ratio of the Aid flow (current US$) in Sierra Leone in 1990 to that in 1991?
Offer a terse response. 0.29. What is the ratio of the Aid flow (current US$) in Other small states in 1990 to that in 1993?
Your answer should be very brief. 0.77. What is the ratio of the Aid flow (current US$) in Ecuador in 1990 to that in 1993?
Provide a succinct answer. 0.5. What is the ratio of the Aid flow (current US$) of Rwanda in 1990 to that in 1993?
Make the answer very short. 0.04. What is the ratio of the Aid flow (current US$) in Sierra Leone in 1990 to that in 1993?
Your response must be concise. 0.28. What is the ratio of the Aid flow (current US$) of Other small states in 1990 to that in 1994?
Keep it short and to the point. 1.27. What is the ratio of the Aid flow (current US$) in Ecuador in 1990 to that in 1994?
Your answer should be very brief. 0.32. What is the ratio of the Aid flow (current US$) in Rwanda in 1990 to that in 1994?
Give a very brief answer. 0.01. What is the ratio of the Aid flow (current US$) in Other small states in 1991 to that in 1993?
Keep it short and to the point. 0.83. What is the ratio of the Aid flow (current US$) of Ecuador in 1991 to that in 1993?
Provide a short and direct response. 1.84. What is the ratio of the Aid flow (current US$) of Rwanda in 1991 to that in 1993?
Provide a succinct answer. 0.53. What is the ratio of the Aid flow (current US$) of Other small states in 1991 to that in 1994?
Ensure brevity in your answer.  1.37. What is the ratio of the Aid flow (current US$) of Ecuador in 1991 to that in 1994?
Offer a very short reply. 1.16. What is the ratio of the Aid flow (current US$) of Rwanda in 1991 to that in 1994?
Keep it short and to the point. 0.15. What is the ratio of the Aid flow (current US$) in Sierra Leone in 1991 to that in 1994?
Provide a short and direct response. 12. What is the ratio of the Aid flow (current US$) in Other small states in 1993 to that in 1994?
Provide a short and direct response. 1.65. What is the ratio of the Aid flow (current US$) of Ecuador in 1993 to that in 1994?
Your answer should be compact. 0.63. What is the ratio of the Aid flow (current US$) in Rwanda in 1993 to that in 1994?
Offer a terse response. 0.28. What is the ratio of the Aid flow (current US$) in Sierra Leone in 1993 to that in 1994?
Make the answer very short. 12.33. What is the difference between the highest and the second highest Aid flow (current US$) of Other small states?
Offer a very short reply. 1.41e+07. What is the difference between the highest and the second highest Aid flow (current US$) of Ecuador?
Offer a very short reply. 3.70e+05. What is the difference between the highest and the second highest Aid flow (current US$) in Rwanda?
Provide a succinct answer. 8.76e+06. What is the difference between the highest and the lowest Aid flow (current US$) in Other small states?
Keep it short and to the point. 4.78e+07. What is the difference between the highest and the lowest Aid flow (current US$) of Ecuador?
Provide a succinct answer. 2.61e+06. What is the difference between the highest and the lowest Aid flow (current US$) in Rwanda?
Your response must be concise. 1.21e+07. What is the difference between the highest and the lowest Aid flow (current US$) of Sierra Leone?
Offer a very short reply. 6.80e+05. 